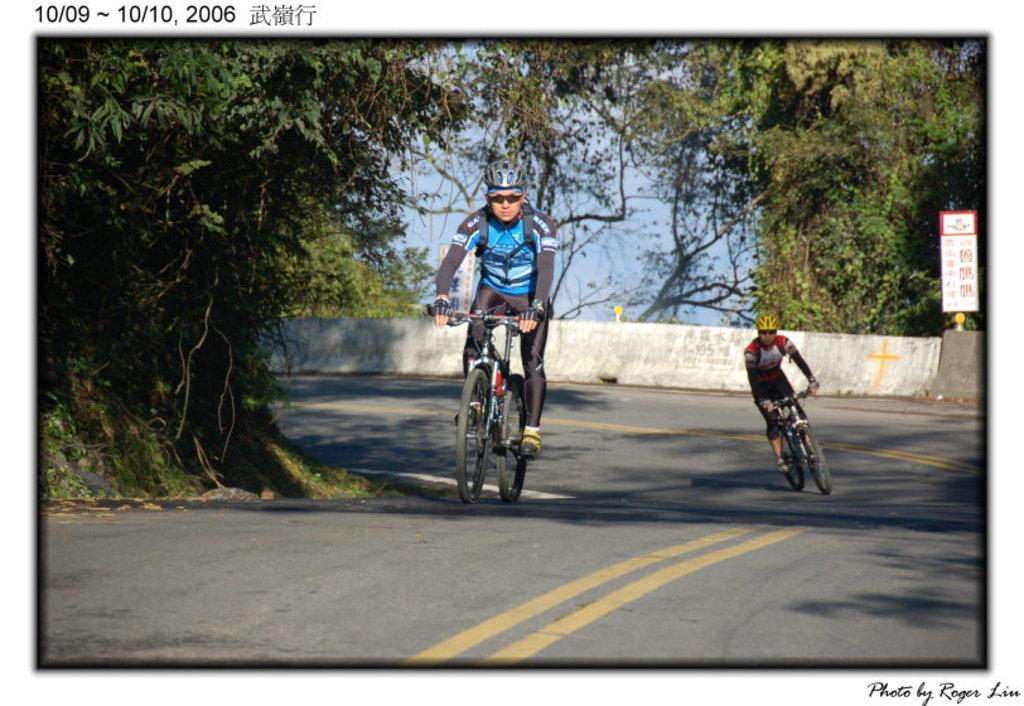How would you summarize this image in a sentence or two? In this image I can see a man who is riding a bicycle on the road. Here we have a tree, a sky and a fence on the road. 